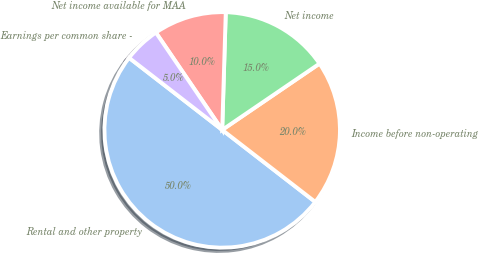<chart> <loc_0><loc_0><loc_500><loc_500><pie_chart><fcel>Rental and other property<fcel>Income before non-operating<fcel>Net income<fcel>Net income available for MAA<fcel>Earnings per common share -<nl><fcel>50.0%<fcel>20.0%<fcel>15.0%<fcel>10.0%<fcel>5.0%<nl></chart> 